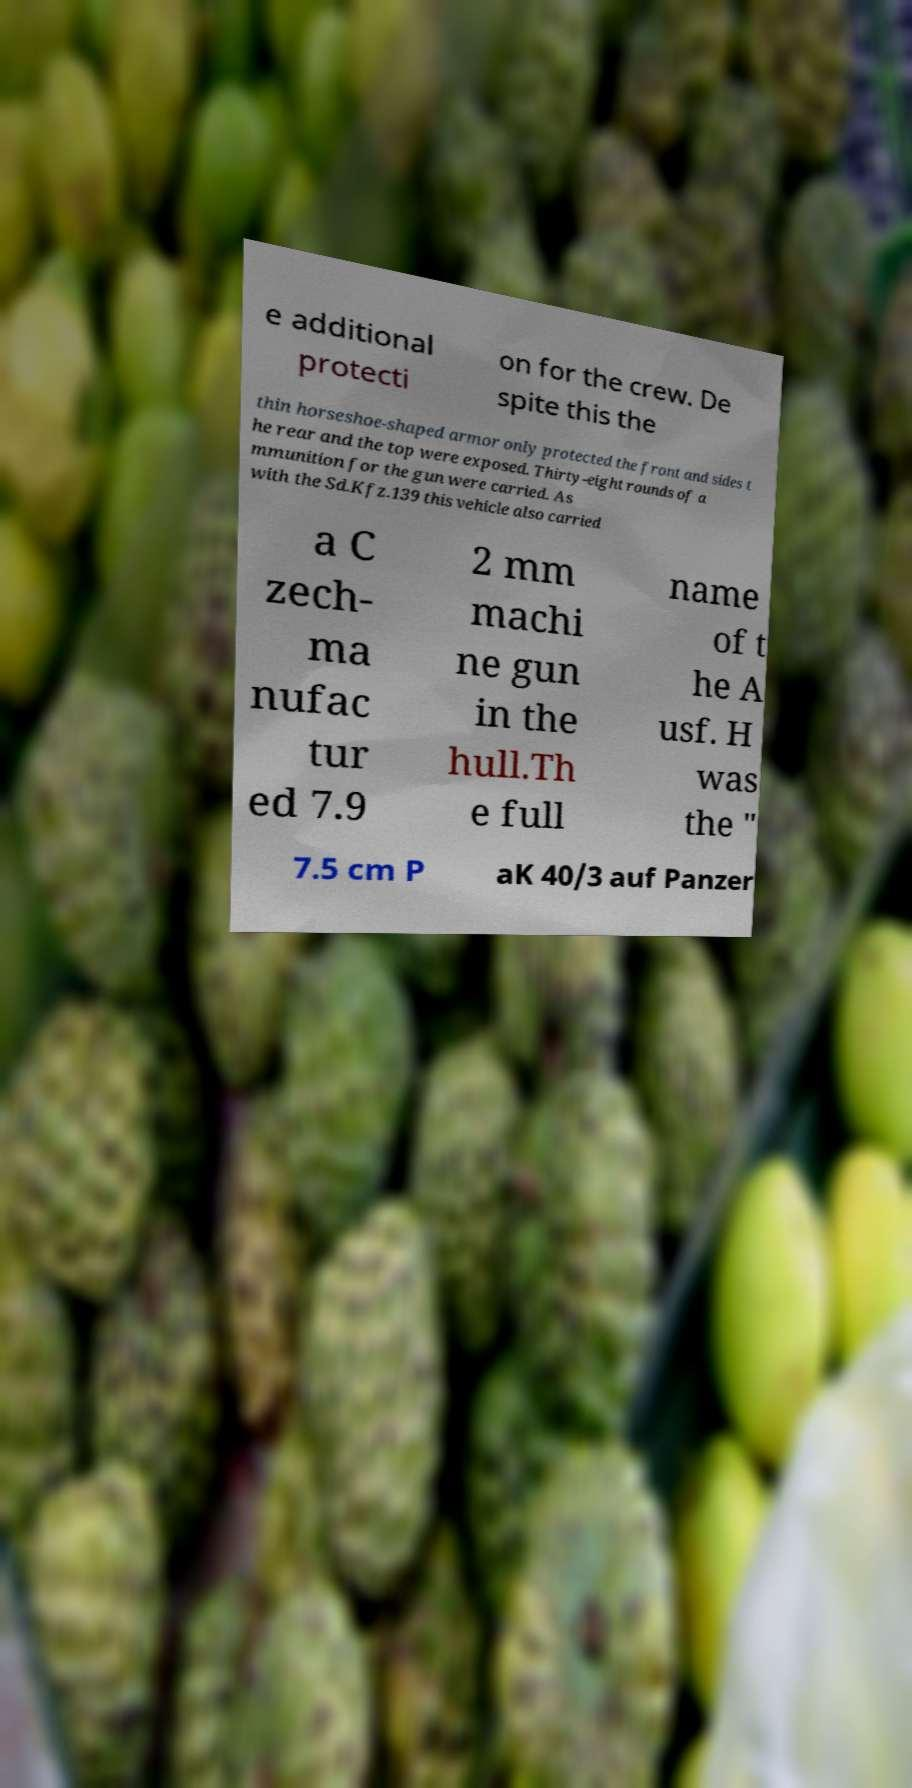What messages or text are displayed in this image? I need them in a readable, typed format. e additional protecti on for the crew. De spite this the thin horseshoe-shaped armor only protected the front and sides t he rear and the top were exposed. Thirty-eight rounds of a mmunition for the gun were carried. As with the Sd.Kfz.139 this vehicle also carried a C zech- ma nufac tur ed 7.9 2 mm machi ne gun in the hull.Th e full name of t he A usf. H was the " 7.5 cm P aK 40/3 auf Panzer 